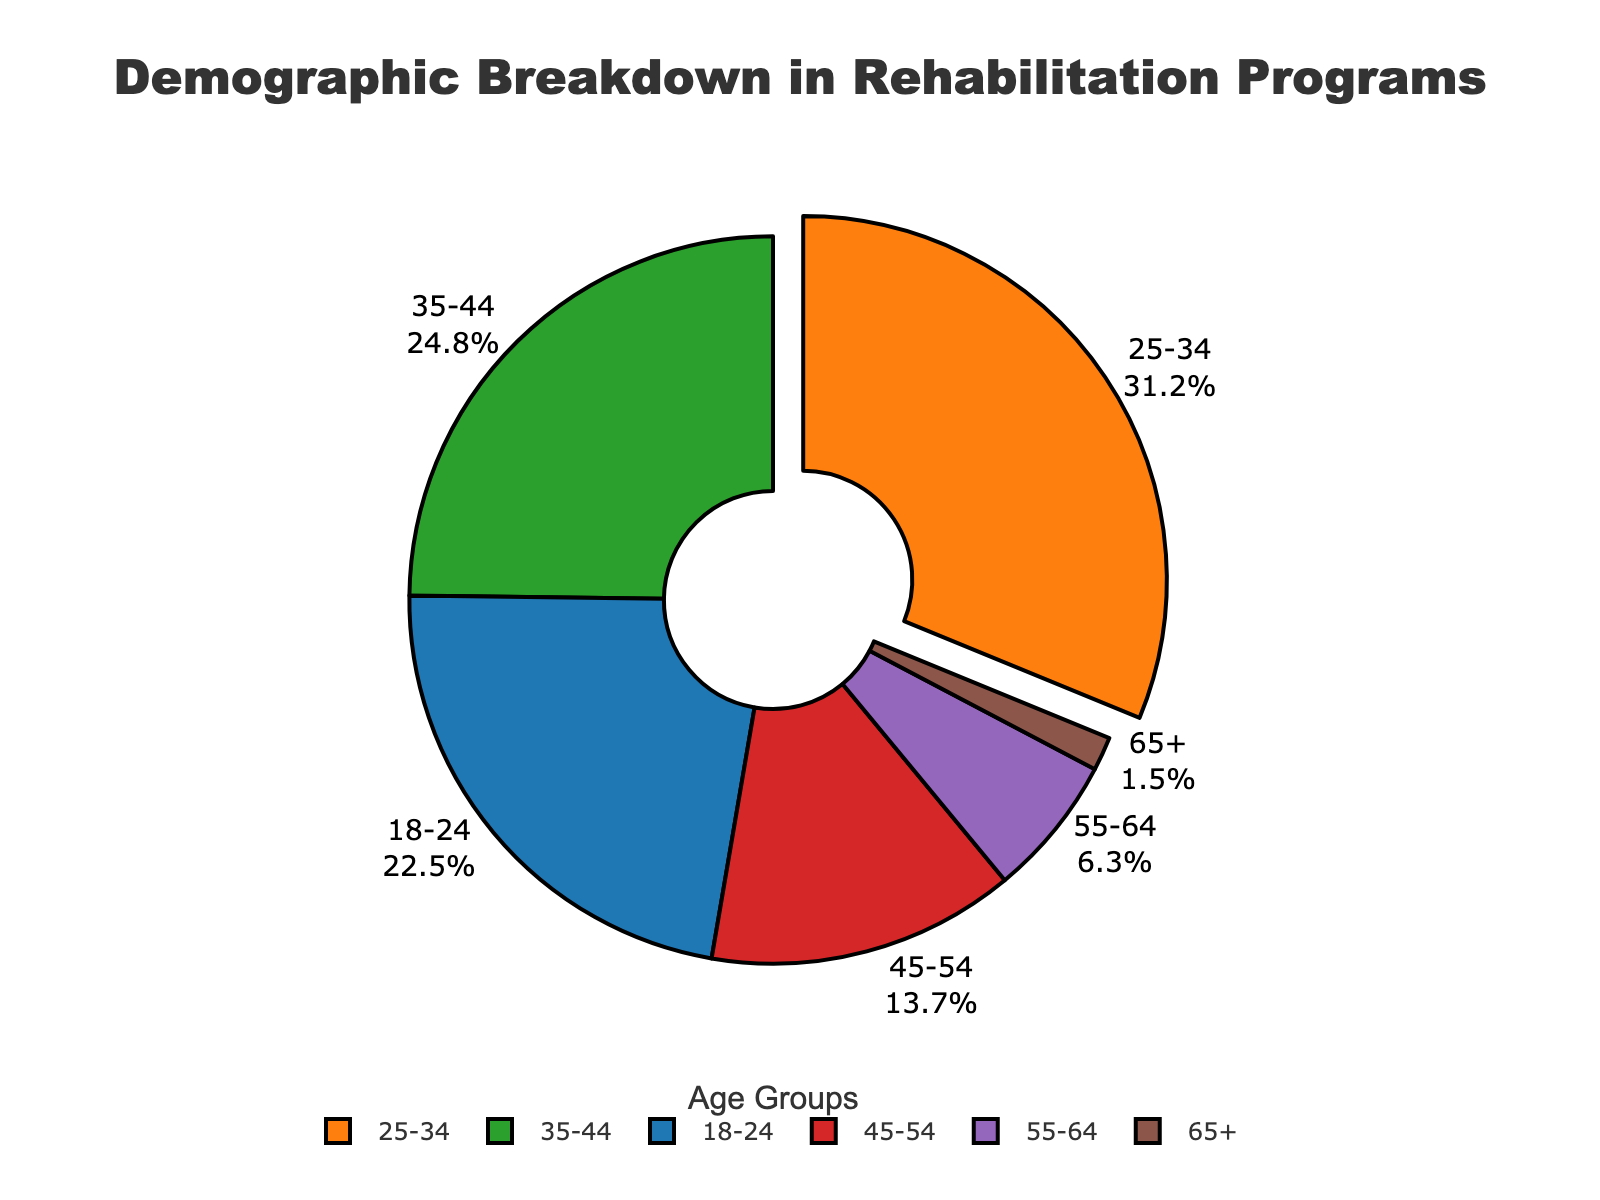Which age group has the largest percentage in rehabilitation programs? By looking at the pie chart, the segment with the largest area is visually identifiable, and it represents the age group 25-34.
Answer: 25-34 Which age group has the smallest percentage in rehabilitation programs? The segment with the smallest area is easily identifiable as representing the age group 65+.
Answer: 65+ What is the percentage difference between the age group 25-34 and 18-24? The percentage for 25-34 is 31.2% and for 18-24 is 22.5%. The difference can be calculated as 31.2% - 22.5% = 8.7%.
Answer: 8.7% How many age groups have a percentage less than 10%? Visually inspect the pie chart to identify the segments representing less than 10%. These segments are 55-64 and 65+, making a total of 2 age groups.
Answer: 2 What is the combined percentage of the age groups 35-44 and 45-54? The percentage for 35-44 is 24.8% and for 45-54 is 13.7%. Summing them gives 24.8% + 13.7% = 38.5%.
Answer: 38.5% Is the percentage of the age group 35-44 greater than that of 18-24? By comparing the values, the percentage for 35-44 is 24.8% and for 18-24 is 22.5%. Since 24.8% > 22.5%, the answer is yes.
Answer: Yes What percentage of individuals aged 45-54 are in rehabilitation programs compared to those aged 55-64? The percentage for 45-54 is 13.7% and for 55-64 is 6.3%. Comparing these by performing a division gives 13.7% / 6.3% ≈ 2.17. Thus, individuals aged 45-54 are in rehabilitation programs about 2.17 times more than those aged 55-64.
Answer: 2.17 If you sum the percentages of the oldest two age groups (55-64 and 65+), what is the result? Adding the percentages of the age groups 55-64 (6.3%) and 65+ (1.5%) gives 6.3% + 1.5% = 7.8%.
Answer: 7.8% 